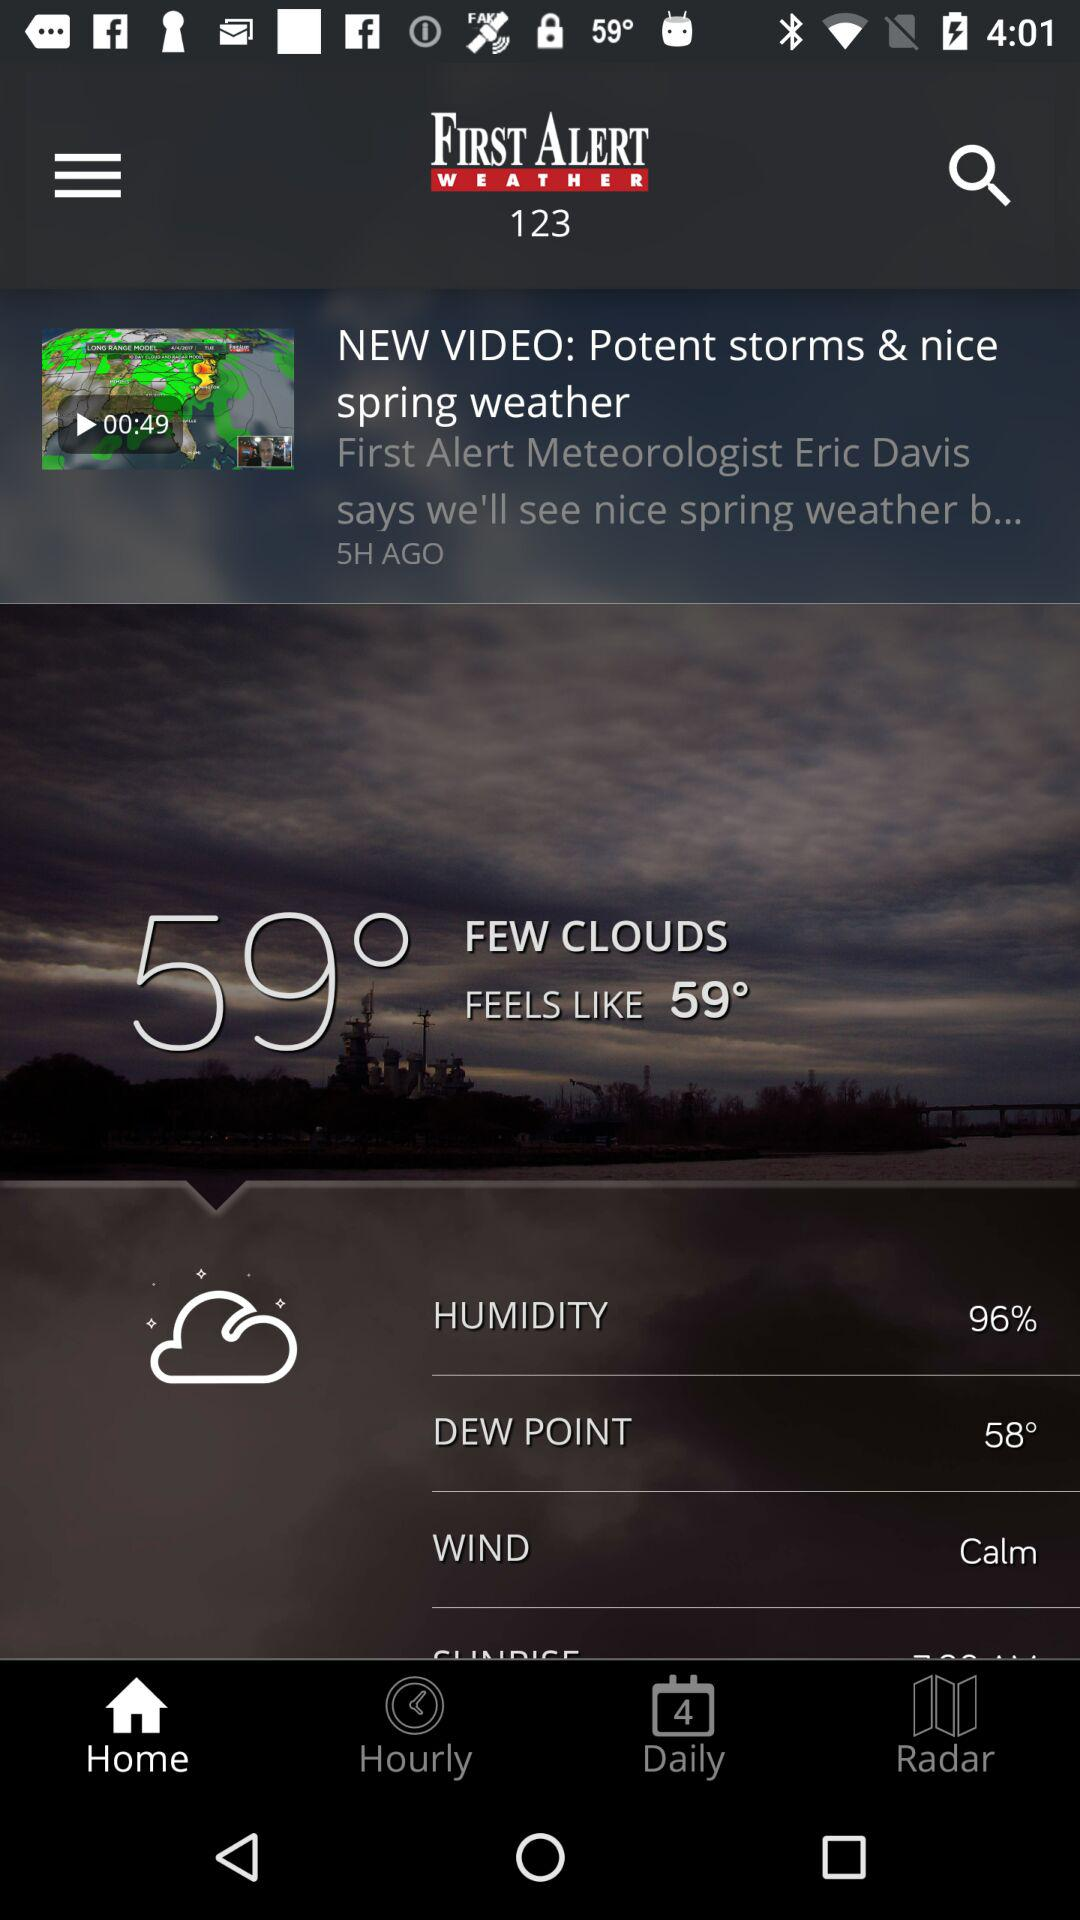What is the wind speed?
Answer the question using a single word or phrase. Calm 